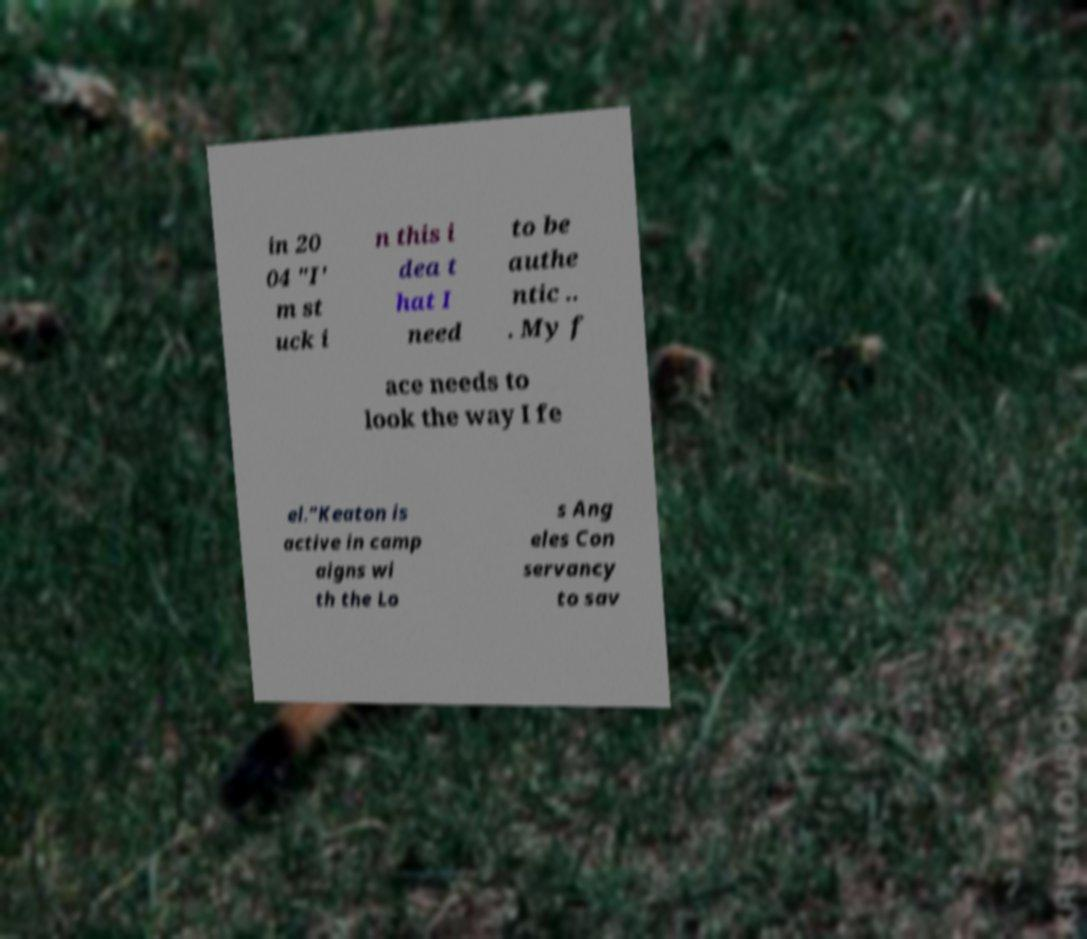Please read and relay the text visible in this image. What does it say? in 20 04 "I' m st uck i n this i dea t hat I need to be authe ntic .. . My f ace needs to look the way I fe el."Keaton is active in camp aigns wi th the Lo s Ang eles Con servancy to sav 